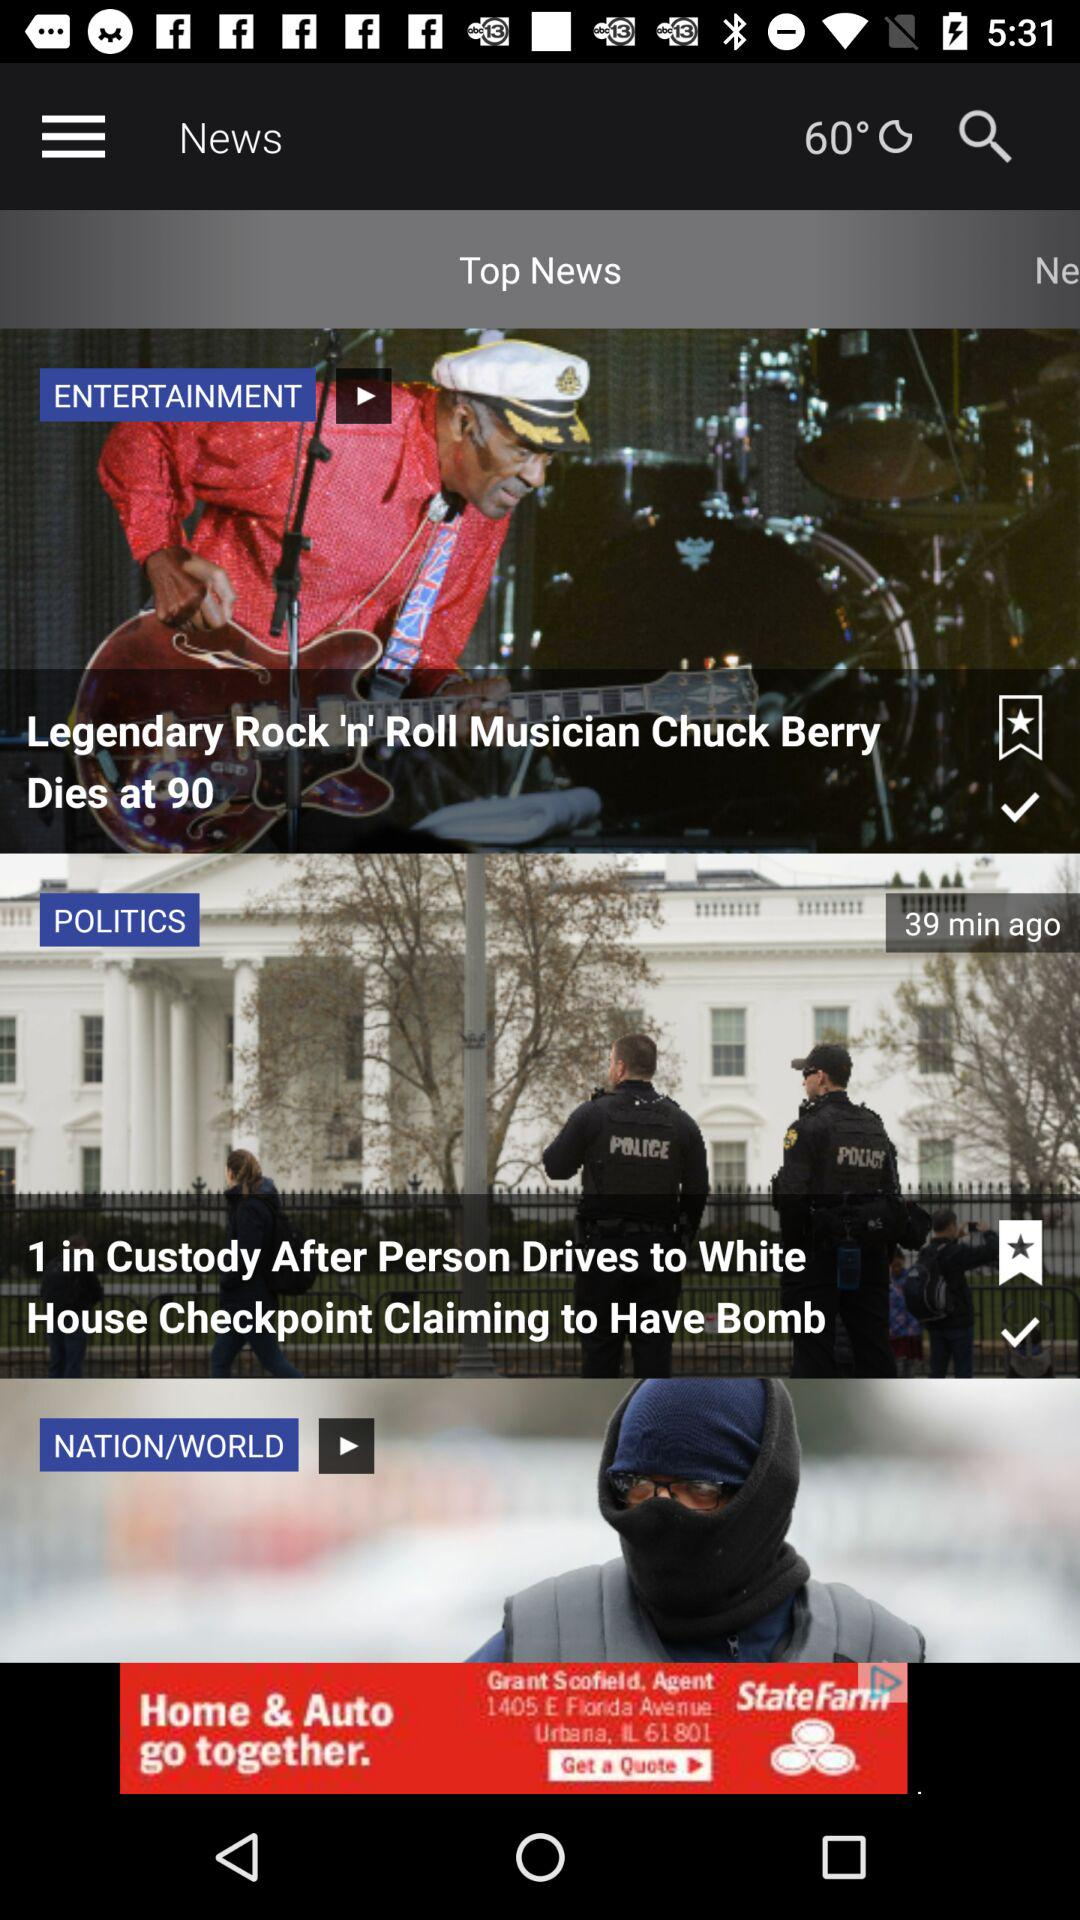What are top news? The top news are "Legendary Rock 'n' Roll Musician Chuck Berry Dies at 90" and "1 in Custody After Person Drives to White House Checkpoint Claiming To Have Bomb". 